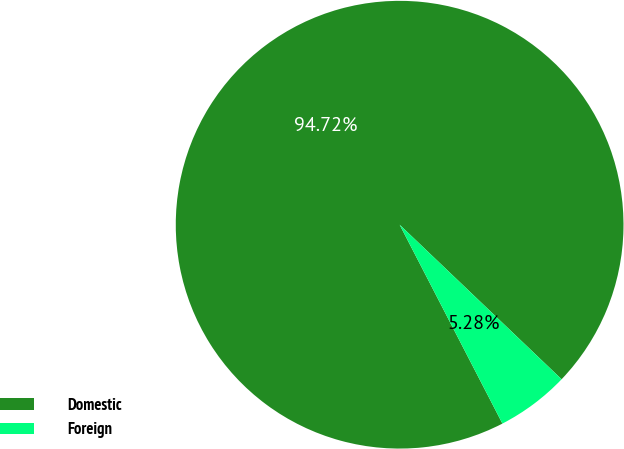Convert chart. <chart><loc_0><loc_0><loc_500><loc_500><pie_chart><fcel>Domestic<fcel>Foreign<nl><fcel>94.72%<fcel>5.28%<nl></chart> 